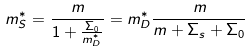<formula> <loc_0><loc_0><loc_500><loc_500>m _ { S } ^ { * } = \frac { m } { 1 + \frac { \Sigma _ { 0 } } { m _ { D } ^ { * } } } = m _ { D } ^ { * } \frac { m } { m + \Sigma _ { s } + \Sigma _ { 0 } }</formula> 